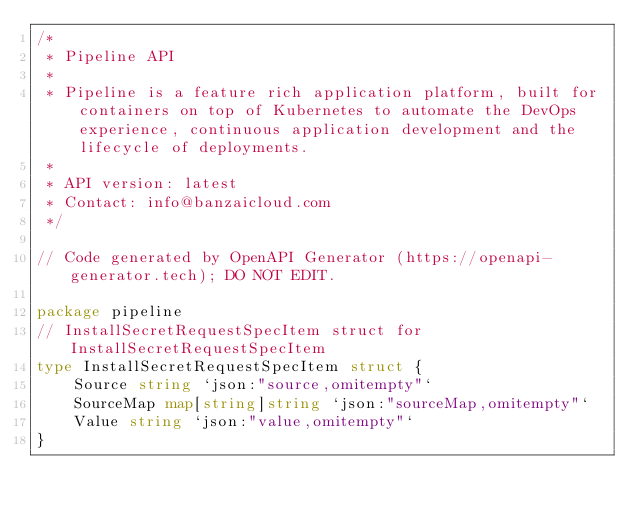<code> <loc_0><loc_0><loc_500><loc_500><_Go_>/*
 * Pipeline API
 *
 * Pipeline is a feature rich application platform, built for containers on top of Kubernetes to automate the DevOps experience, continuous application development and the lifecycle of deployments. 
 *
 * API version: latest
 * Contact: info@banzaicloud.com
 */

// Code generated by OpenAPI Generator (https://openapi-generator.tech); DO NOT EDIT.

package pipeline
// InstallSecretRequestSpecItem struct for InstallSecretRequestSpecItem
type InstallSecretRequestSpecItem struct {
	Source string `json:"source,omitempty"`
	SourceMap map[string]string `json:"sourceMap,omitempty"`
	Value string `json:"value,omitempty"`
}
</code> 